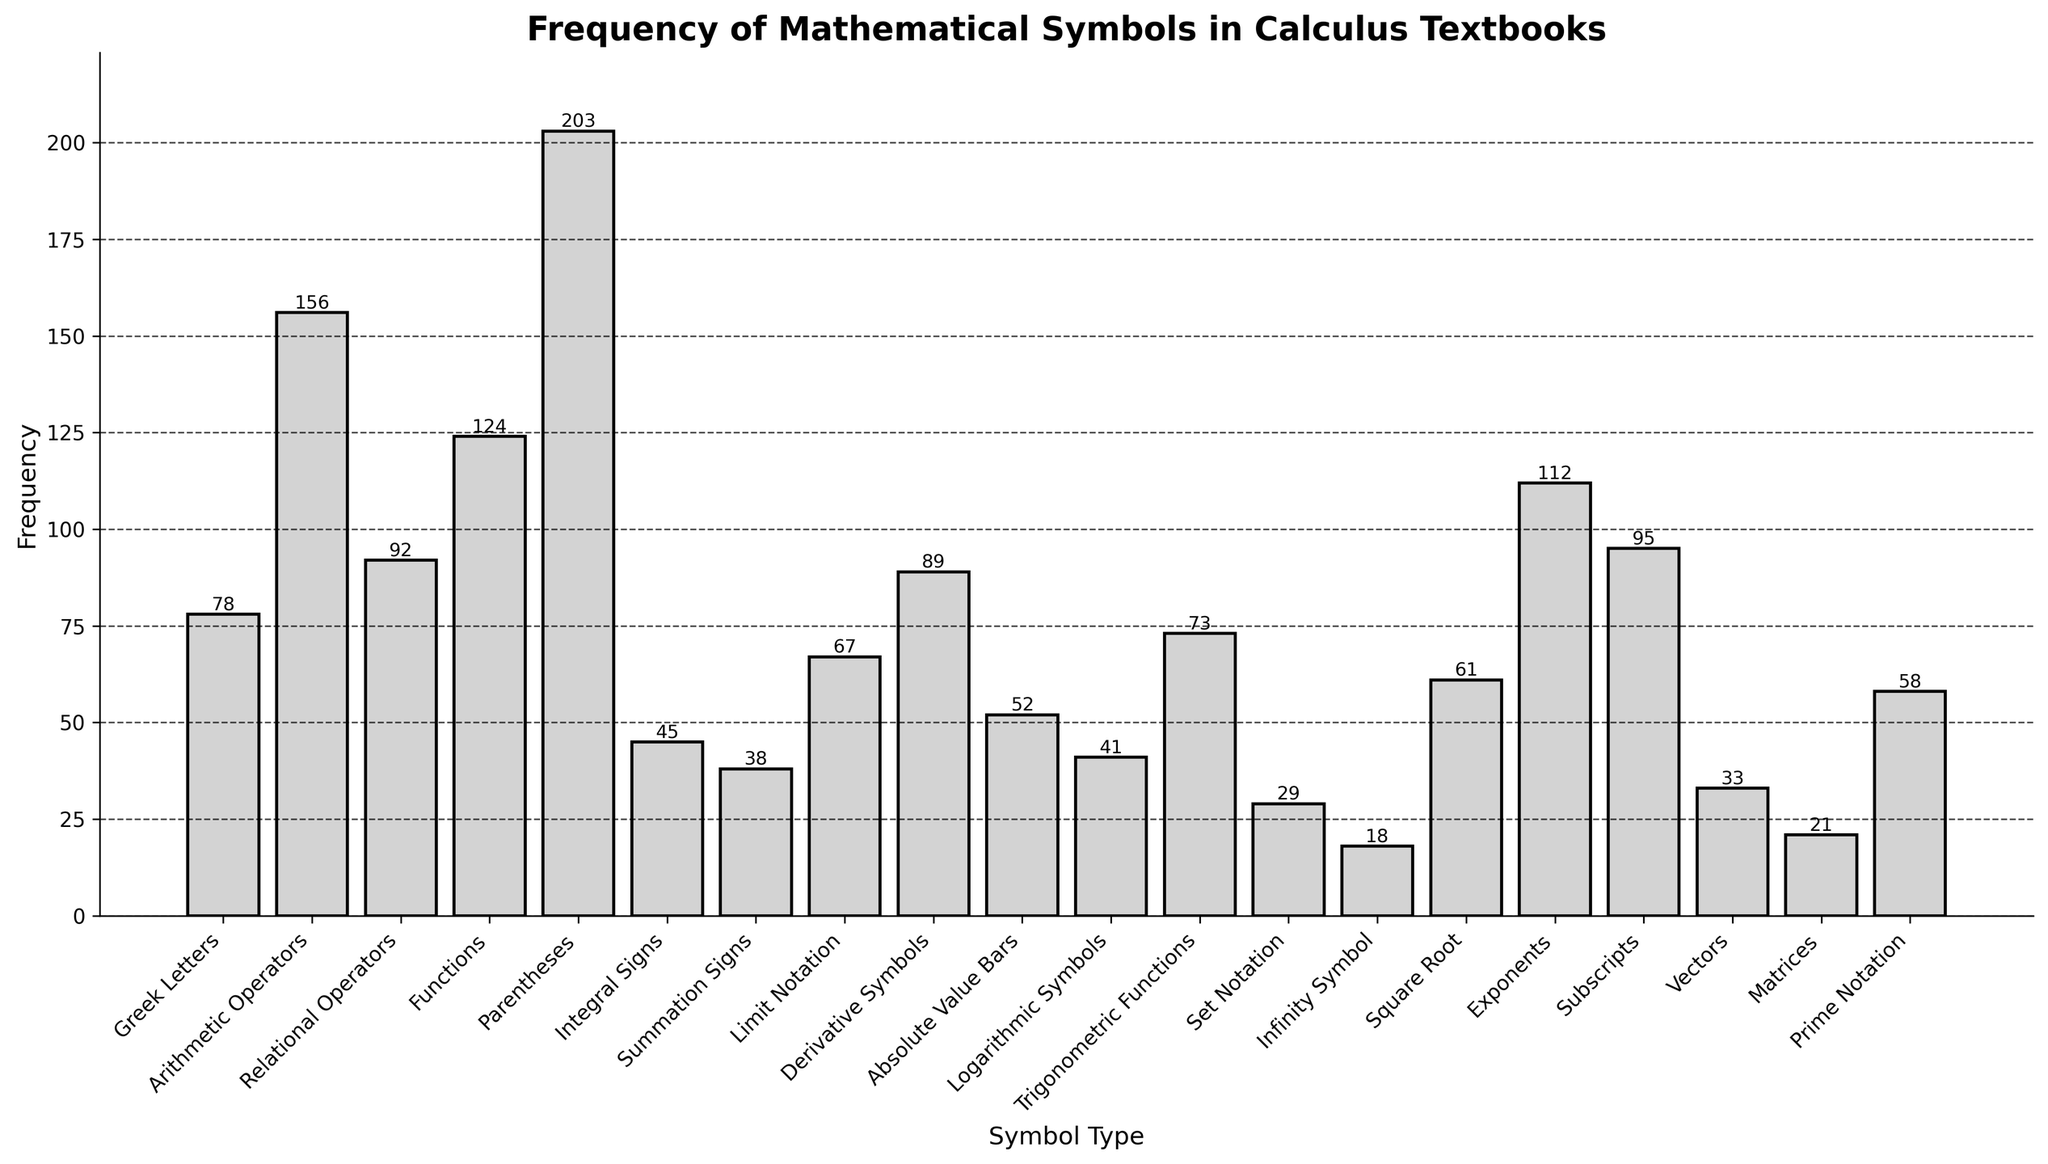What symbol type has the highest frequency? Looking at the height of the bars in the bar chart, the symbol type with the highest bar represents the highest frequency. "Parentheses" has the highest frequency.
Answer: Parentheses Which symbol type has the lowest frequency? Observing the bars' height, the smallest bar corresponds to the lowest frequency. "Infinity Symbol" has the lowest frequency.
Answer: Infinity Symbol How many more times are Arithmetic Operators used than Integral Signs? The height of the bar for Arithmetic Operators is 156, and for Integral Signs, it's 45. Subtract the frequency of Integral Signs from Arithmetic Operators: 156 - 45 = 111.
Answer: 111 What’s the combined frequency of Greek Letters, Relational Operators, and Trigonometric Functions? Add the respective frequencies: Greek Letters (78) + Relational Operators (92) + Trigonometric Functions (73). So, 78 + 92 + 73 = 243.
Answer: 243 Are Functions or Exponents used more frequently, and by how much? The height of the bar for Functions is 124, and for Exponents, it's 112. Subtract the frequency of Exponents from Functions: 124 - 112 = 12.
Answer: Functions by 12 What is the average frequency of Limit Notation, Derivative Symbols, and Logarithmic Symbols? Add the frequencies of Limit Notation (67), Derivative Symbols (89), and Logarithmic Symbols (41), then divide by 3: (67 + 89 + 41) / 3 ≈ 65.7.
Answer: ~65.7 Which symbol types have a frequency greater than 100? Observing the bar chart, the bars for Arithmetic Operators, Functions, and Parentheses exceed the height corresponding to 100.
Answer: Arithmetic Operators, Functions, Parentheses Is the frequency of Subscripts higher or lower than that of Derivative Symbols? Comparing the bar heights, Subscripts (95) is higher than Derivative Symbols (89).
Answer: Higher How does the frequency of Summation Signs compare to that of Vectors? The bar height for Summation Signs is 38, while for Vectors, it's 33, showing Summation Signs are more frequent.
Answer: Summation Signs are more frequent by 5 What's the sum of the frequencies for Prime Notation and Absolute Value Bars? Add the frequencies for Prime Notation (58) and Absolute Value Bars (52): 58 + 52 = 110.
Answer: 110 